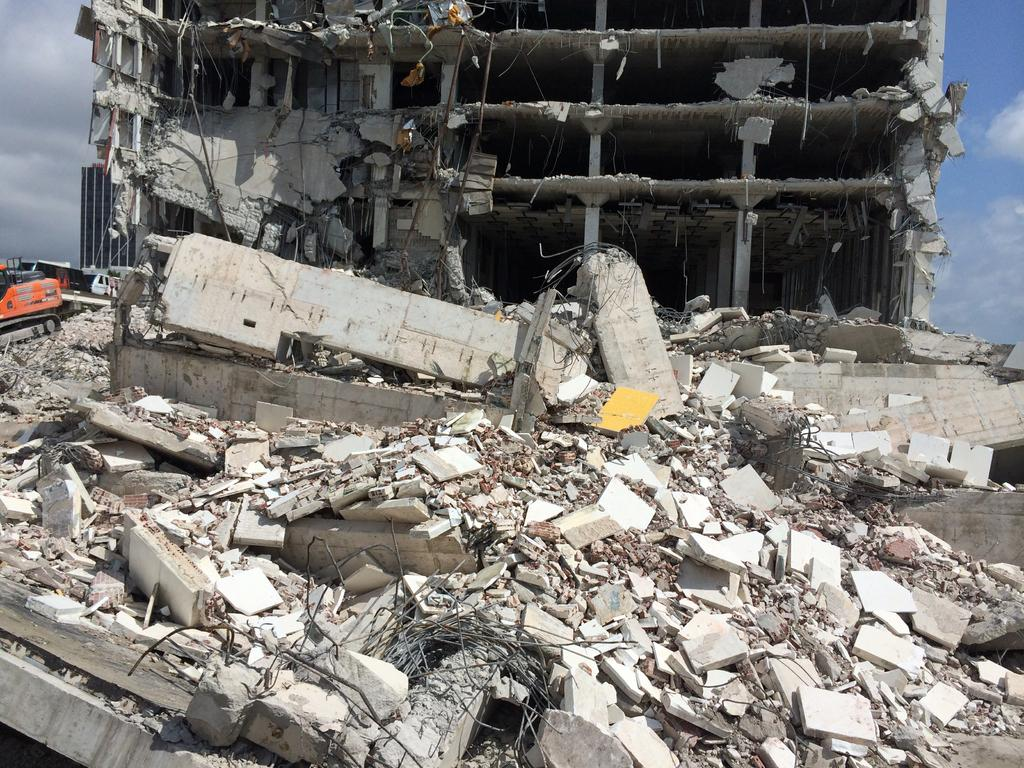What is the condition of the building in the image? The building in the image is damaged. What type of vehicle is present in the image? There is a JCB truck in the image. What can be seen in the background of the image? There is a building and the sky visible in the background of the image. How many bulbs are hanging from the damaged building in the image? There is no mention of bulbs in the image, so it is not possible to determine their presence or quantity. 